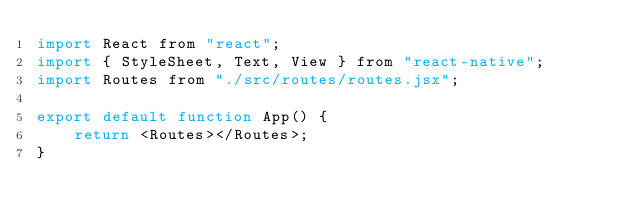<code> <loc_0><loc_0><loc_500><loc_500><_JavaScript_>import React from "react";
import { StyleSheet, Text, View } from "react-native";
import Routes from "./src/routes/routes.jsx";

export default function App() {
    return <Routes></Routes>;
}
</code> 